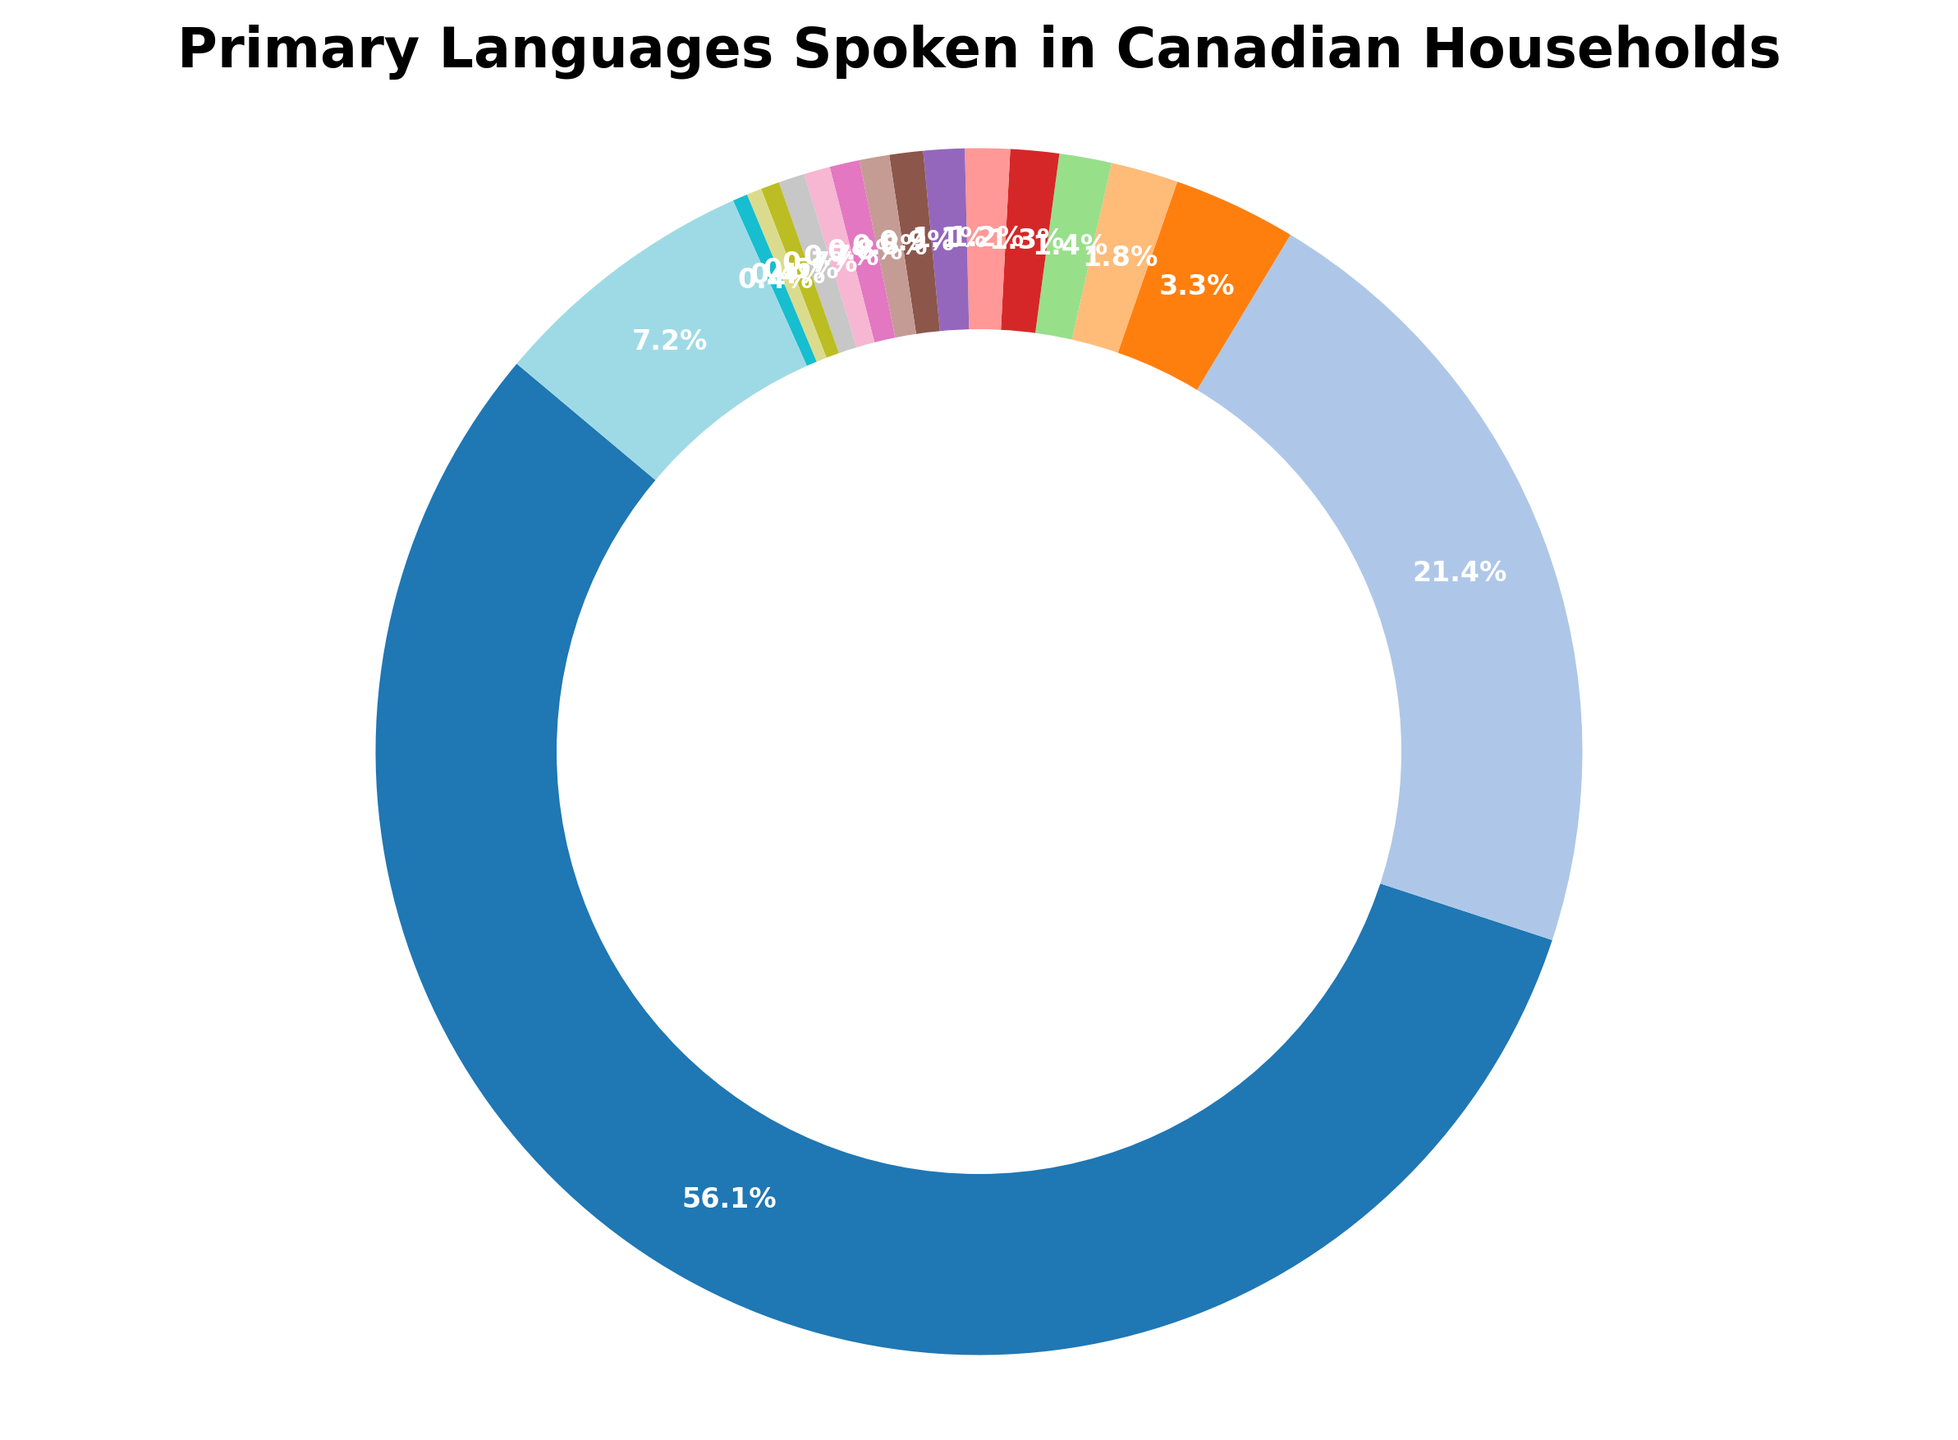What's the most common primary language spoken in Canadian households? By looking at the pie chart, the largest segment represents the most common language. The English segment is the largest, indicating it is the most common.
Answer: English What percentage of Canadian households primarily speak French? By looking at the pie chart, identify the segment labeled "French" and note its corresponding percentage value. The segment is labeled with 21.4%.
Answer: 21.4% How many languages are spoken by a larger percentage of the population than Punjabi? Compare the percentage of Punjabi (1.4%) with other languages on the chart: English, French, Mandarin, Cantonese, and Spanish are greater than 1.4%. There are 5 languages.
Answer: 5 Which language is spoken by a similar percentage of Canadian households as Tagalog? Examine the pie chart and find the language with a percentage close to Tagalog's (1.2%). Spanish has a very close percentage (1.3%).
Answer: Spanish What is the combined percentage of households speaking Mandarin, Cantonese, and Punjabi? Add the percentage values of Mandarin (3.3%), Cantonese (1.8%), and Punjabi (1.4%). The combined value is 3.3 + 1.8 + 1.4 = 6.5%.
Answer: 6.5% Which language is spoken by fewer households, Urdu or Arabic? Find and compare the segments labeled "Urdu" (0.8%) and "Arabic" (1.1%). Urdu is spoken by fewer households.
Answer: Urdu What is the combined percentage of households speaking Korean, Farsi, and Russian? Add the percentage values of Korean (0.5%), Farsi (0.4%), and Russian (0.4%). The combined value is 0.5 + 0.4 + 0.4 = 1.3%.
Answer: 1.3% How does the percentage of Italian-speaking households compare to German-speaking households? Compare the percentage of Italian (0.9%) and German (0.8%). Italian is spoken by a slightly higher percentage of households than German.
Answer: Italian How much more prevalent is Mandarin than Cantonese? Subtract the percentage of Cantonese (1.8%) from Mandarin (3.3%). The difference is 3.3 - 1.8 = 1.5%.
Answer: 1.5% What language has a percentage almost equal to 0.8%? Identify languages with a percentage around 0.8%. Both German and Urdu each represent 0.8%.
Answer: German/Urdu 